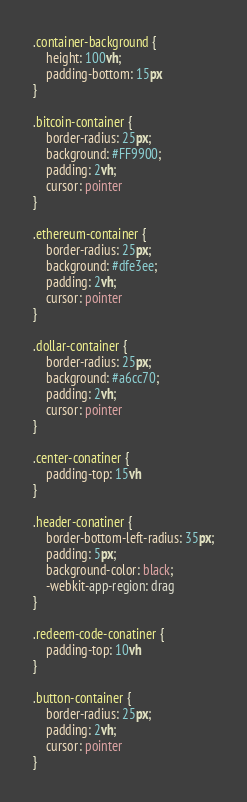<code> <loc_0><loc_0><loc_500><loc_500><_CSS_>.container-background {
    height: 100vh;
    padding-bottom: 15px
}

.bitcoin-container {
    border-radius: 25px;
    background: #FF9900;
    padding: 2vh;
    cursor: pointer
}

.ethereum-container {
    border-radius: 25px;
    background: #dfe3ee;
    padding: 2vh;
    cursor: pointer
}

.dollar-container {
    border-radius: 25px;
    background: #a6cc70;
    padding: 2vh;
    cursor: pointer
}

.center-conatiner {
    padding-top: 15vh
}

.header-conatiner {
    border-bottom-left-radius: 35px;
    padding: 5px;
    background-color: black;
    -webkit-app-region: drag
}

.redeem-code-conatiner {
    padding-top: 10vh
}

.button-container {
    border-radius: 25px;
    padding: 2vh;
    cursor: pointer
}</code> 